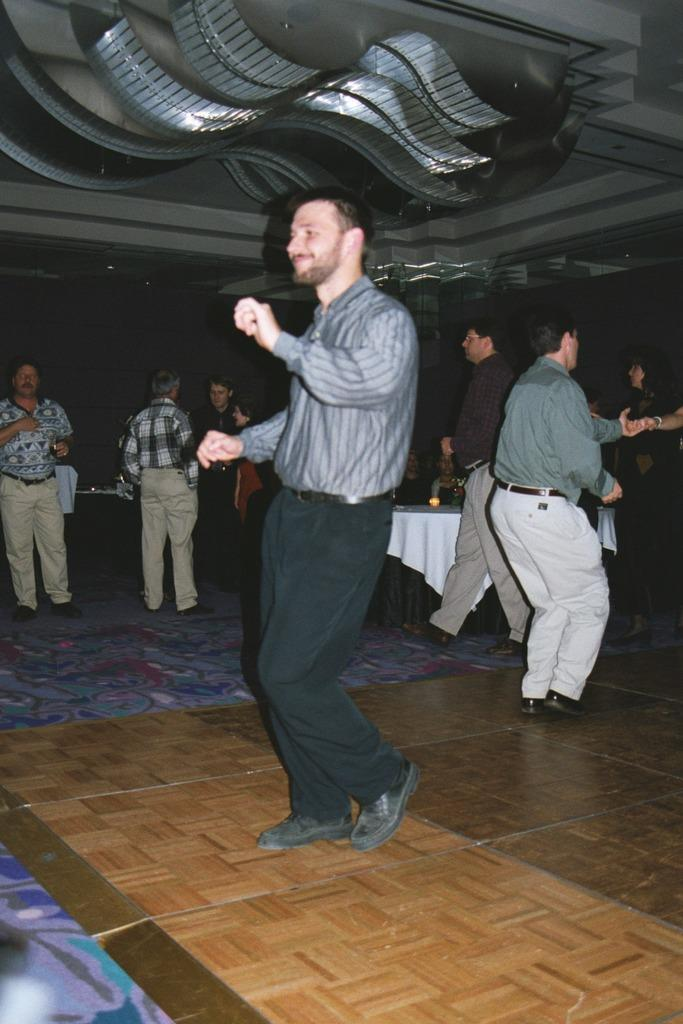How many people are present in the image? There are many people in the image. What are some of the activities the people are engaged in? Some people are dancing, standing, and walking. Can you describe the table in the background? There is a table with a white cloth in the background. What can be seen on the ceiling in the image? There are decorations on the ceiling. What type of pie is being served on the hill in the image? There is no pie or hill present in the image; it features people engaged in various activities and a table with a white cloth in the background. 